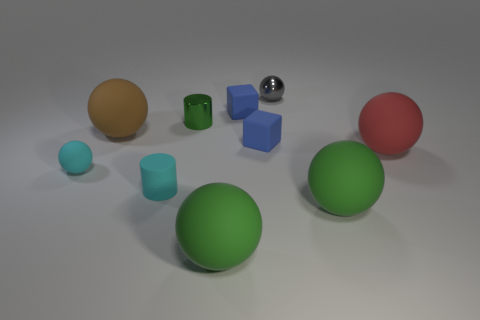What is the color of the matte cube that is in front of the green thing behind the large red matte ball?
Keep it short and to the point. Blue. There is a small rubber thing that is behind the tiny green thing; is it the same shape as the small metallic object behind the small green thing?
Make the answer very short. No. What is the shape of the gray shiny object that is the same size as the cyan matte sphere?
Keep it short and to the point. Sphere. There is a tiny ball that is the same material as the red object; what is its color?
Offer a terse response. Cyan. Is the shape of the big brown rubber thing the same as the small green metal thing that is left of the red matte ball?
Your response must be concise. No. There is a thing that is the same color as the small rubber cylinder; what is it made of?
Provide a short and direct response. Rubber. What is the material of the cyan object that is the same size as the matte cylinder?
Your answer should be very brief. Rubber. Are there any rubber objects that have the same color as the shiny ball?
Your answer should be compact. No. There is a matte object that is on the left side of the tiny green metal object and in front of the tiny cyan matte sphere; what is its shape?
Provide a succinct answer. Cylinder. How many big things have the same material as the green cylinder?
Make the answer very short. 0. 